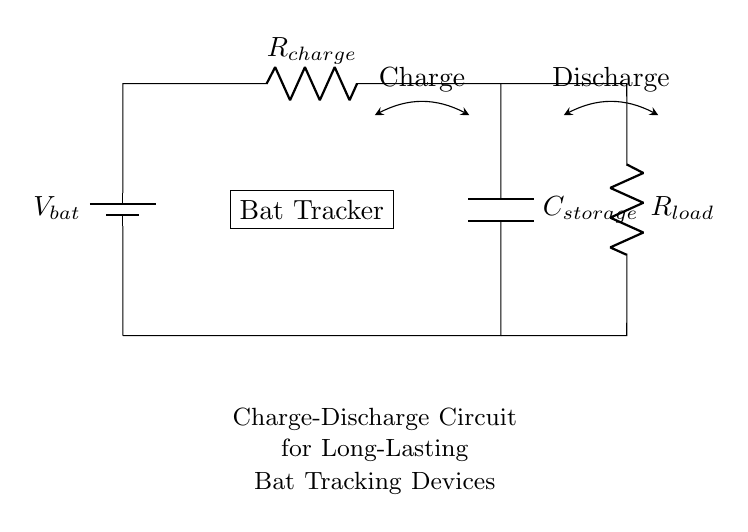What is the voltage of the battery? The voltage of the battery is indicated as V_bat in the circuit. Since it's a battery symbol, it provides a constant voltage to the circuit.
Answer: V_bat What are the components present in the circuit? The circuit has a battery, a resistor for charging (R_charge), a capacitor (C_storage), and a resistor for the load (R_load). These components are essential in the charge-discharge process.
Answer: Battery, R_charge, C_storage, R_load What happens during charging? During charging, the battery supplies voltage to the circuit, causing current to flow through R_charge, which in turn charges the capacitor C_storage. The arrows show the direction of current flow during this process.
Answer: Current flows to charge the capacitor What is the function of the capacitor in this circuit? The capacitor C_storage stores electrical energy when charged and can release it when needed during the discharge phase, providing power to the bat tracker asynchronously.
Answer: Energy storage How does the load resistor affect the discharge process? The load resistor R_load regulates the current flow when the capacitor discharges, affecting the rate at which the stored energy is released to the bat tracker. A higher resistance will lead to a slower discharge.
Answer: Regulates current flow during discharge What type of circuit is depicted here? The circuit shown is a resistor-capacitor (RC) circuit, which is commonly used to manage the charging and discharging of capacitors in electronic devices, particularly for maintaining power over time.
Answer: Resistor-Capacitor Circuit 